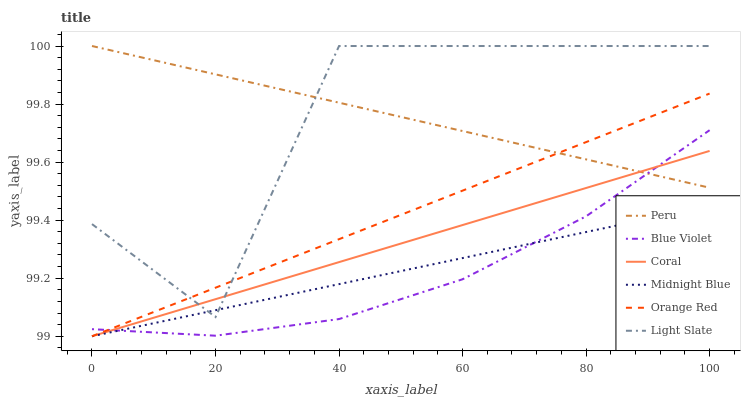Does Blue Violet have the minimum area under the curve?
Answer yes or no. Yes. Does Light Slate have the minimum area under the curve?
Answer yes or no. No. Does Light Slate have the maximum area under the curve?
Answer yes or no. No. Is Coral the smoothest?
Answer yes or no. Yes. Is Light Slate the roughest?
Answer yes or no. Yes. Is Light Slate the smoothest?
Answer yes or no. No. Is Coral the roughest?
Answer yes or no. No. Does Light Slate have the lowest value?
Answer yes or no. No. Does Coral have the highest value?
Answer yes or no. No. Is Midnight Blue less than Peru?
Answer yes or no. Yes. Is Peru greater than Midnight Blue?
Answer yes or no. Yes. Does Midnight Blue intersect Peru?
Answer yes or no. No. 